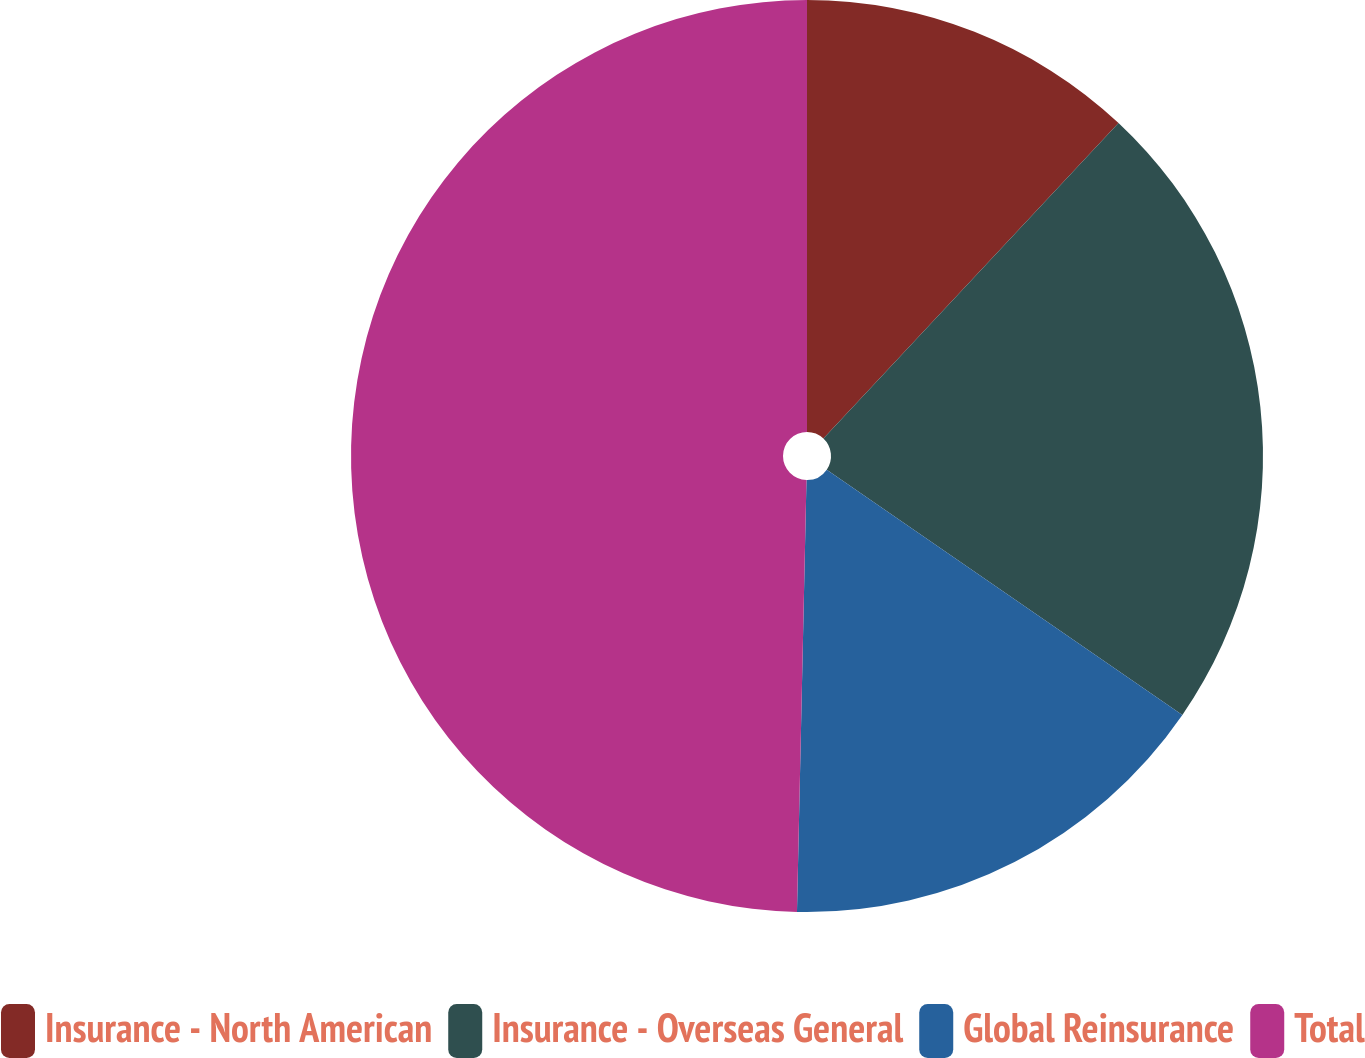Convert chart to OTSL. <chart><loc_0><loc_0><loc_500><loc_500><pie_chart><fcel>Insurance - North American<fcel>Insurance - Overseas General<fcel>Global Reinsurance<fcel>Total<nl><fcel>11.97%<fcel>22.64%<fcel>15.74%<fcel>49.65%<nl></chart> 